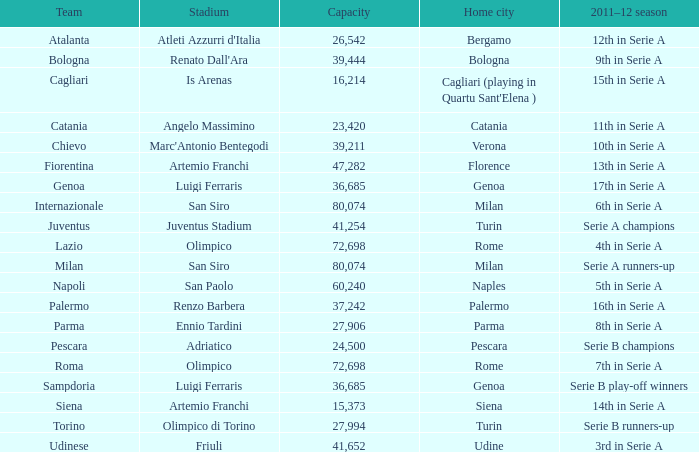What is the home city for angelo massimino stadium? Catania. 